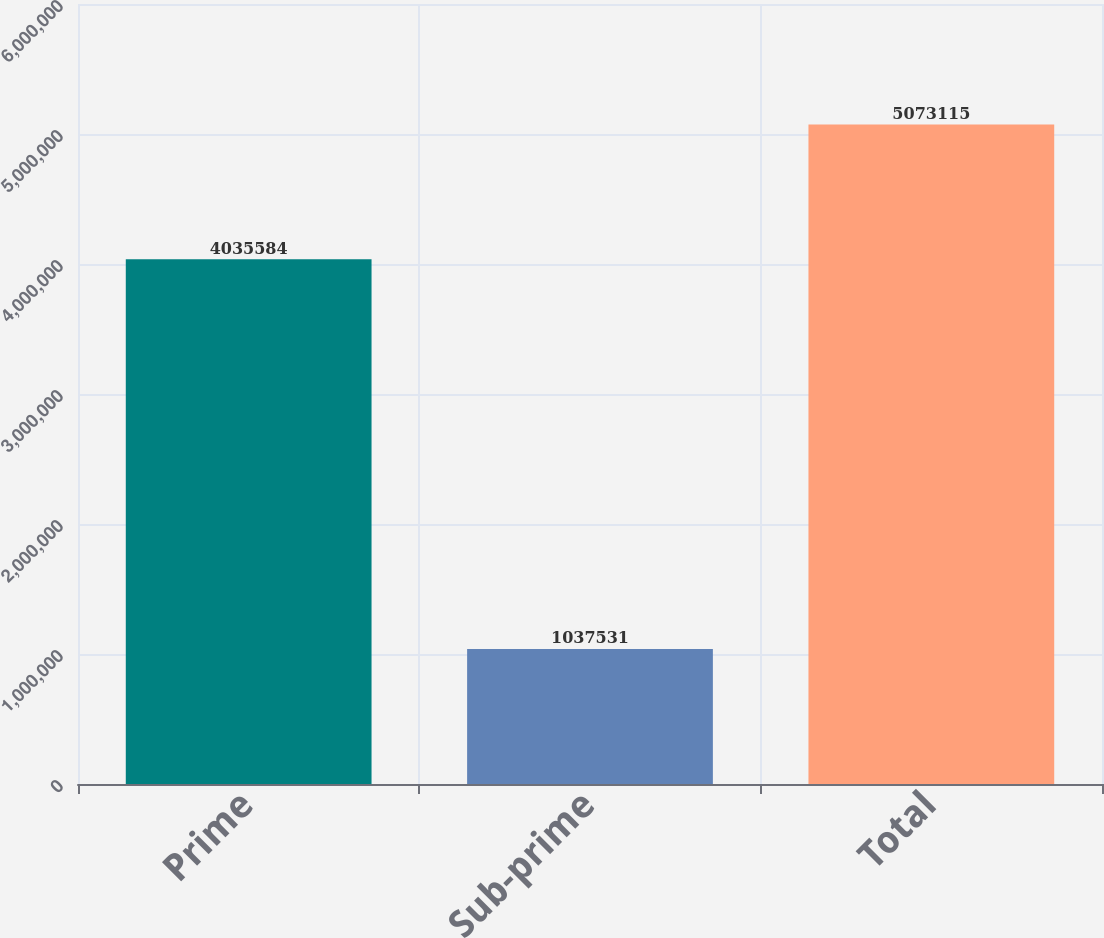<chart> <loc_0><loc_0><loc_500><loc_500><bar_chart><fcel>Prime<fcel>Sub-prime<fcel>Total<nl><fcel>4.03558e+06<fcel>1.03753e+06<fcel>5.07312e+06<nl></chart> 